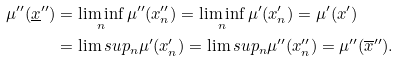Convert formula to latex. <formula><loc_0><loc_0><loc_500><loc_500>\mu ^ { \prime \prime } ( \underline { x } ^ { \prime \prime } ) & = \liminf _ { n } \mu ^ { \prime \prime } ( x _ { n } ^ { \prime \prime } ) = \liminf _ { n } \mu ^ { \prime } ( x _ { n } ^ { \prime } ) = \mu ^ { \prime } ( x ^ { \prime } ) \\ & = \lim s u p _ { n } \mu ^ { \prime } ( x _ { n } ^ { \prime } ) = \lim s u p _ { n } \mu ^ { \prime \prime } ( x _ { n } ^ { \prime \prime } ) = \mu ^ { \prime \prime } ( \overline { x } ^ { \prime \prime } ) .</formula> 